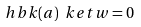Convert formula to latex. <formula><loc_0><loc_0><loc_500><loc_500>\ h b k ( a ) \ k e t { w } = 0</formula> 